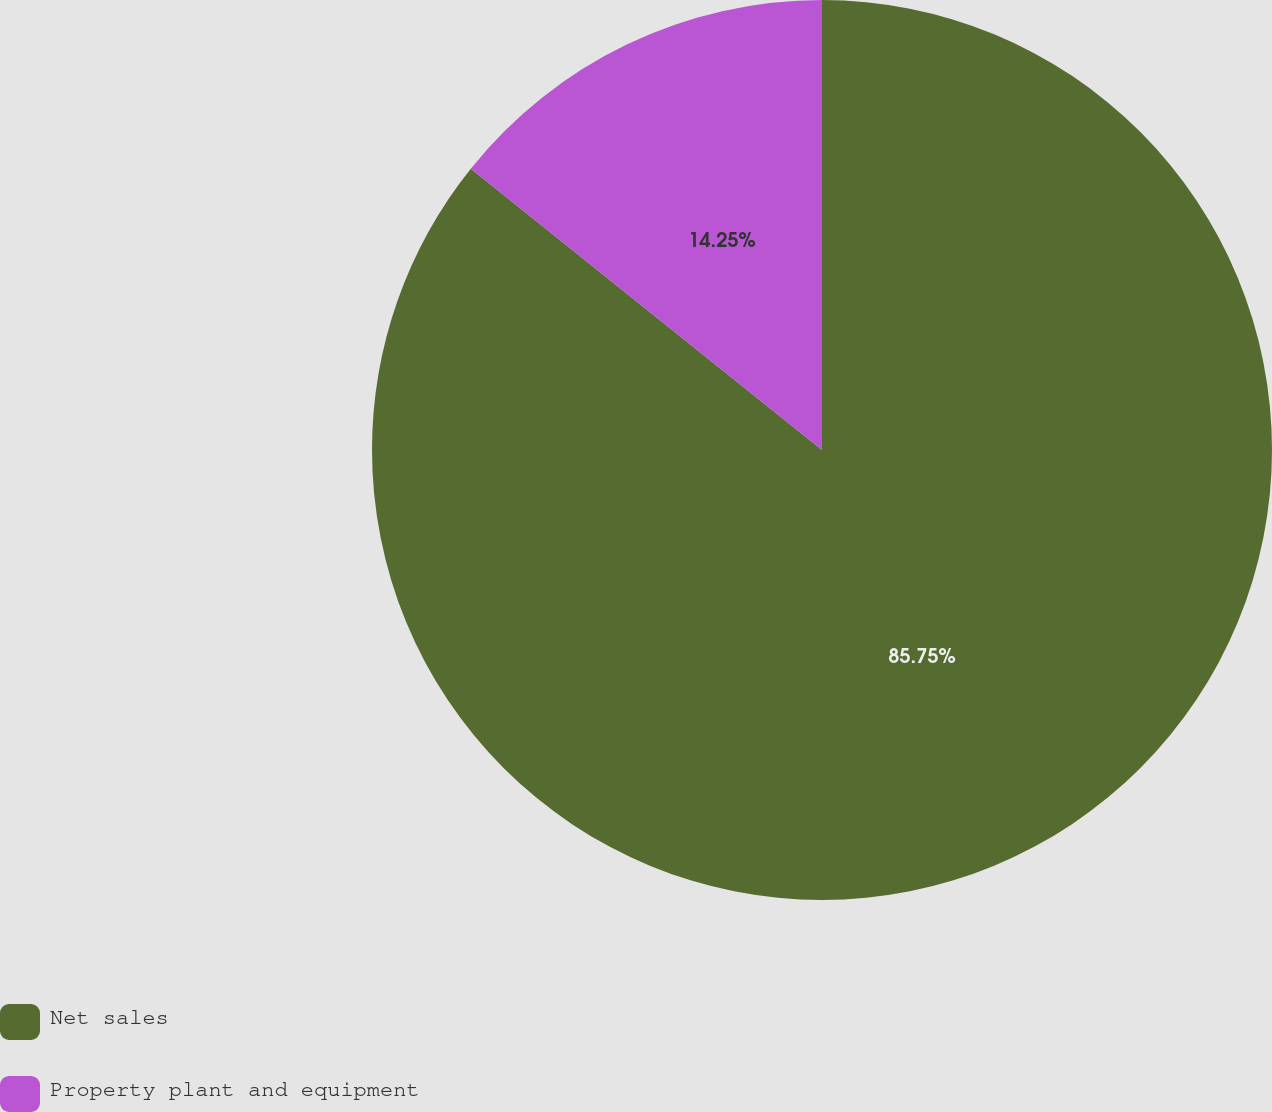Convert chart. <chart><loc_0><loc_0><loc_500><loc_500><pie_chart><fcel>Net sales<fcel>Property plant and equipment<nl><fcel>85.75%<fcel>14.25%<nl></chart> 